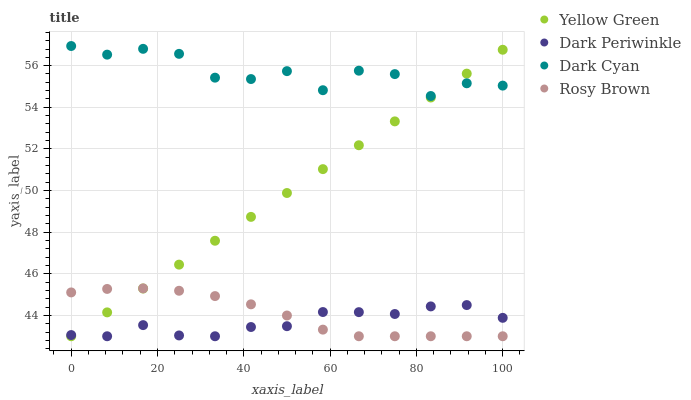Does Dark Periwinkle have the minimum area under the curve?
Answer yes or no. Yes. Does Dark Cyan have the maximum area under the curve?
Answer yes or no. Yes. Does Rosy Brown have the minimum area under the curve?
Answer yes or no. No. Does Rosy Brown have the maximum area under the curve?
Answer yes or no. No. Is Yellow Green the smoothest?
Answer yes or no. Yes. Is Dark Cyan the roughest?
Answer yes or no. Yes. Is Rosy Brown the smoothest?
Answer yes or no. No. Is Rosy Brown the roughest?
Answer yes or no. No. Does Rosy Brown have the lowest value?
Answer yes or no. Yes. Does Dark Cyan have the highest value?
Answer yes or no. Yes. Does Rosy Brown have the highest value?
Answer yes or no. No. Is Dark Periwinkle less than Dark Cyan?
Answer yes or no. Yes. Is Dark Cyan greater than Rosy Brown?
Answer yes or no. Yes. Does Rosy Brown intersect Yellow Green?
Answer yes or no. Yes. Is Rosy Brown less than Yellow Green?
Answer yes or no. No. Is Rosy Brown greater than Yellow Green?
Answer yes or no. No. Does Dark Periwinkle intersect Dark Cyan?
Answer yes or no. No. 